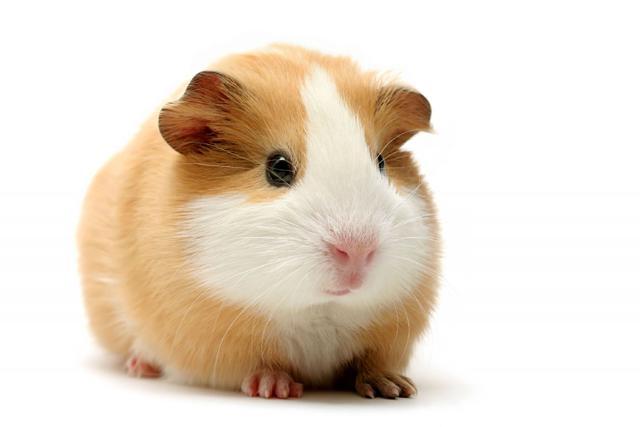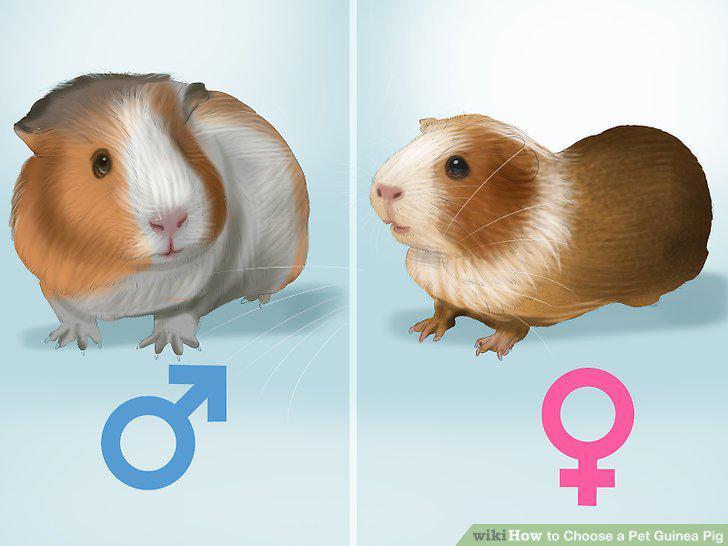The first image is the image on the left, the second image is the image on the right. Examine the images to the left and right. Is the description "A person is holding one of the animals." accurate? Answer yes or no. No. 